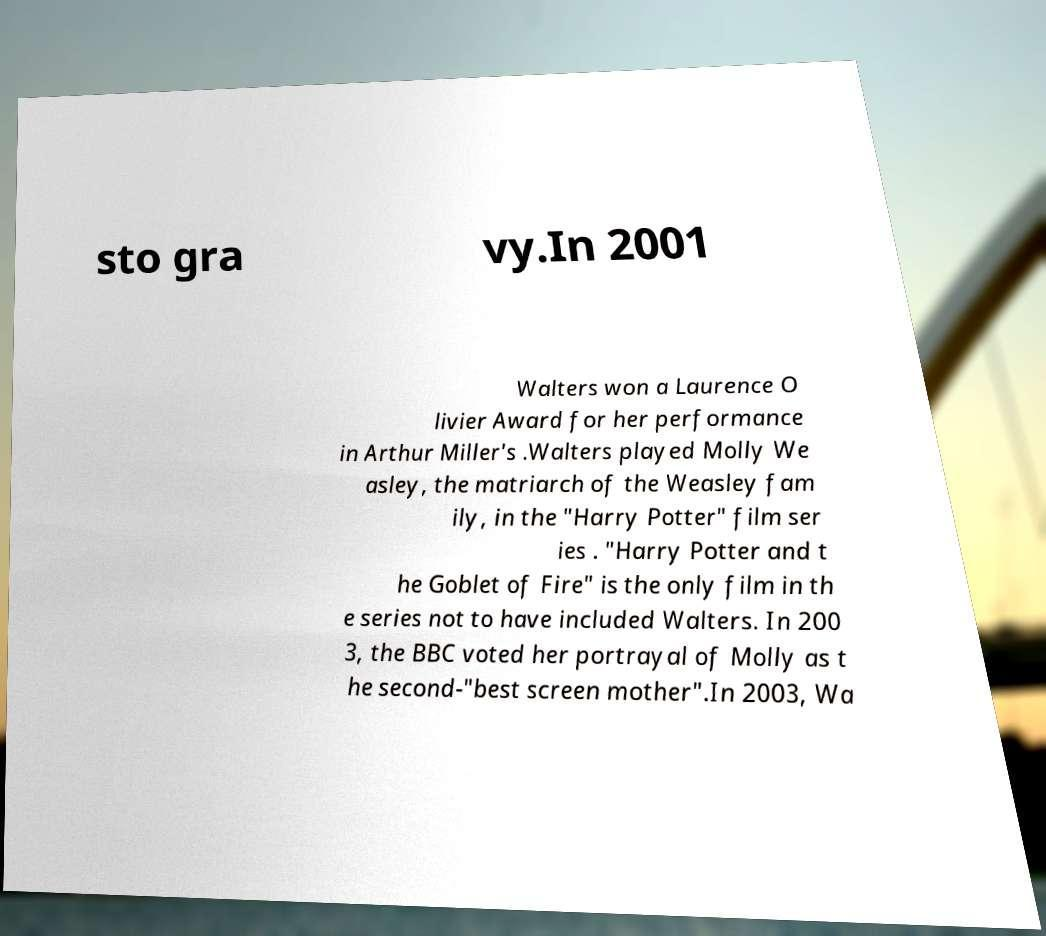There's text embedded in this image that I need extracted. Can you transcribe it verbatim? sto gra vy.In 2001 Walters won a Laurence O livier Award for her performance in Arthur Miller's .Walters played Molly We asley, the matriarch of the Weasley fam ily, in the "Harry Potter" film ser ies . "Harry Potter and t he Goblet of Fire" is the only film in th e series not to have included Walters. In 200 3, the BBC voted her portrayal of Molly as t he second-"best screen mother".In 2003, Wa 